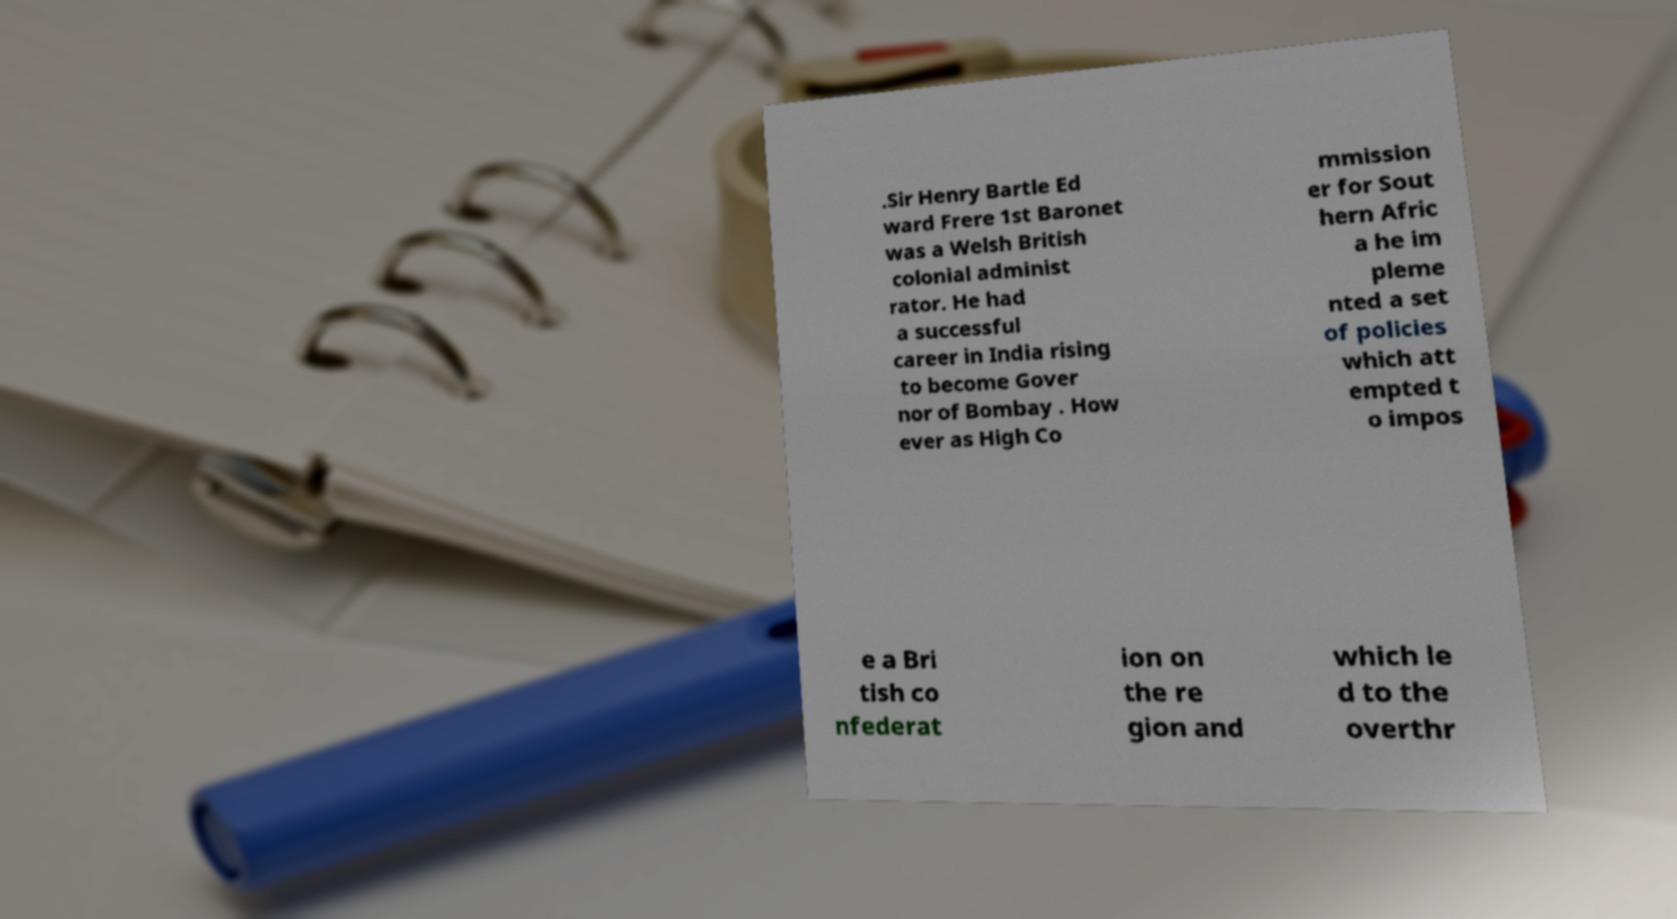Can you read and provide the text displayed in the image?This photo seems to have some interesting text. Can you extract and type it out for me? .Sir Henry Bartle Ed ward Frere 1st Baronet was a Welsh British colonial administ rator. He had a successful career in India rising to become Gover nor of Bombay . How ever as High Co mmission er for Sout hern Afric a he im pleme nted a set of policies which att empted t o impos e a Bri tish co nfederat ion on the re gion and which le d to the overthr 